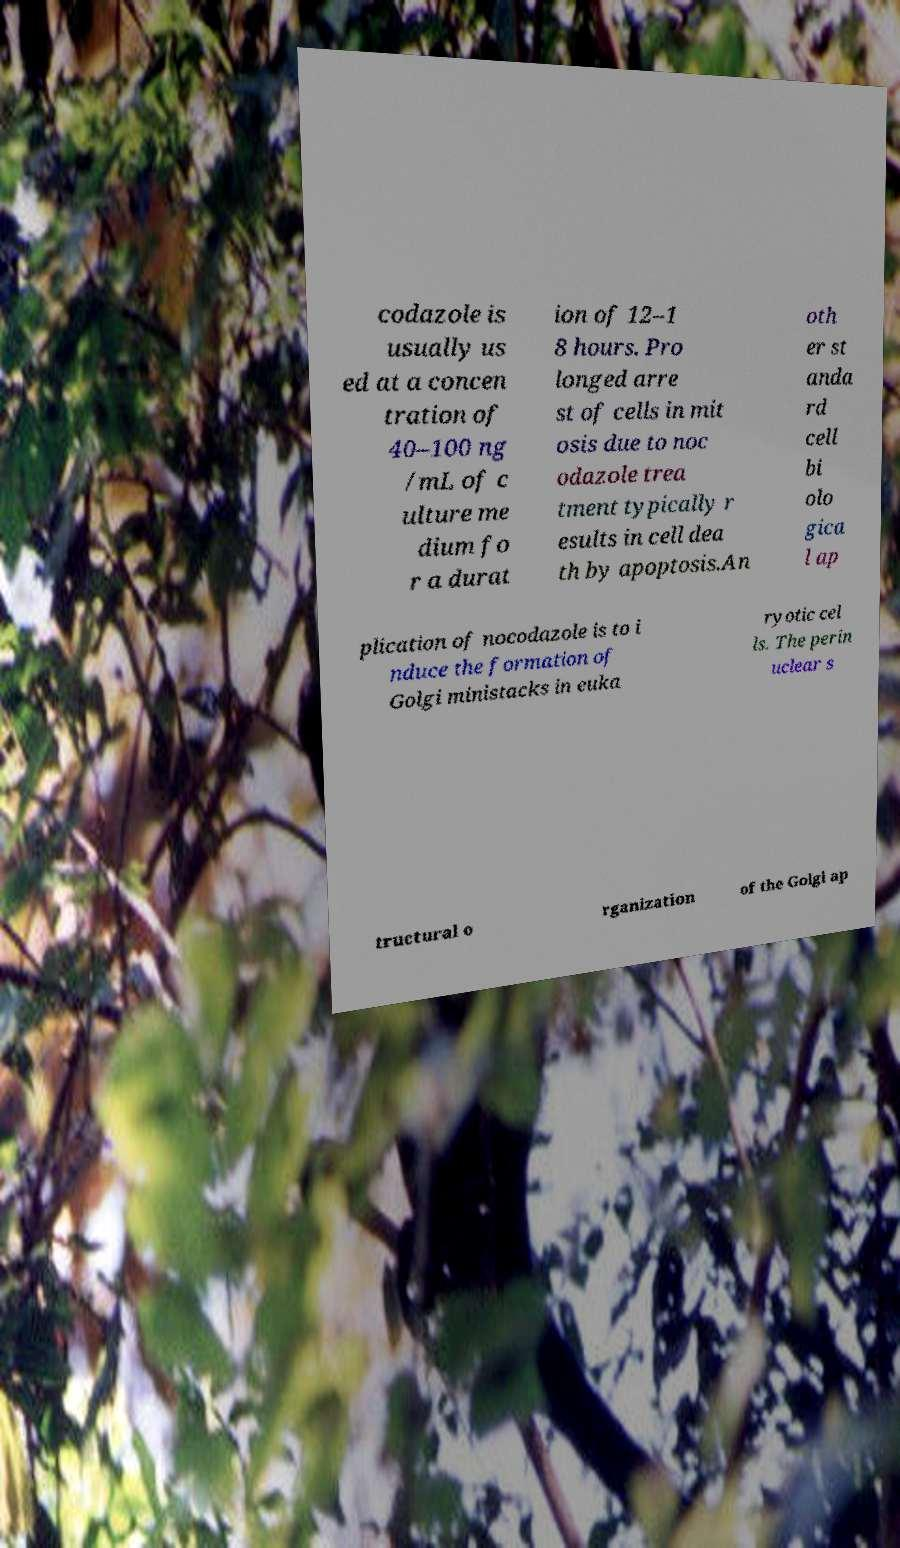Can you read and provide the text displayed in the image?This photo seems to have some interesting text. Can you extract and type it out for me? codazole is usually us ed at a concen tration of 40–100 ng /mL of c ulture me dium fo r a durat ion of 12–1 8 hours. Pro longed arre st of cells in mit osis due to noc odazole trea tment typically r esults in cell dea th by apoptosis.An oth er st anda rd cell bi olo gica l ap plication of nocodazole is to i nduce the formation of Golgi ministacks in euka ryotic cel ls. The perin uclear s tructural o rganization of the Golgi ap 